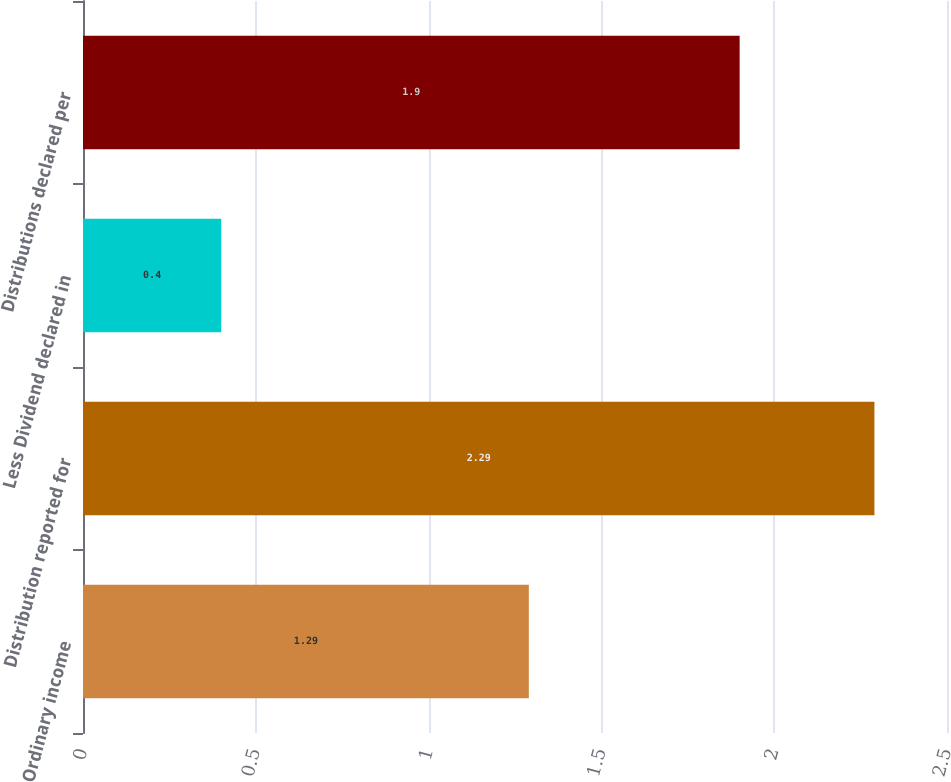<chart> <loc_0><loc_0><loc_500><loc_500><bar_chart><fcel>Ordinary income<fcel>Distribution reported for<fcel>Less Dividend declared in<fcel>Distributions declared per<nl><fcel>1.29<fcel>2.29<fcel>0.4<fcel>1.9<nl></chart> 